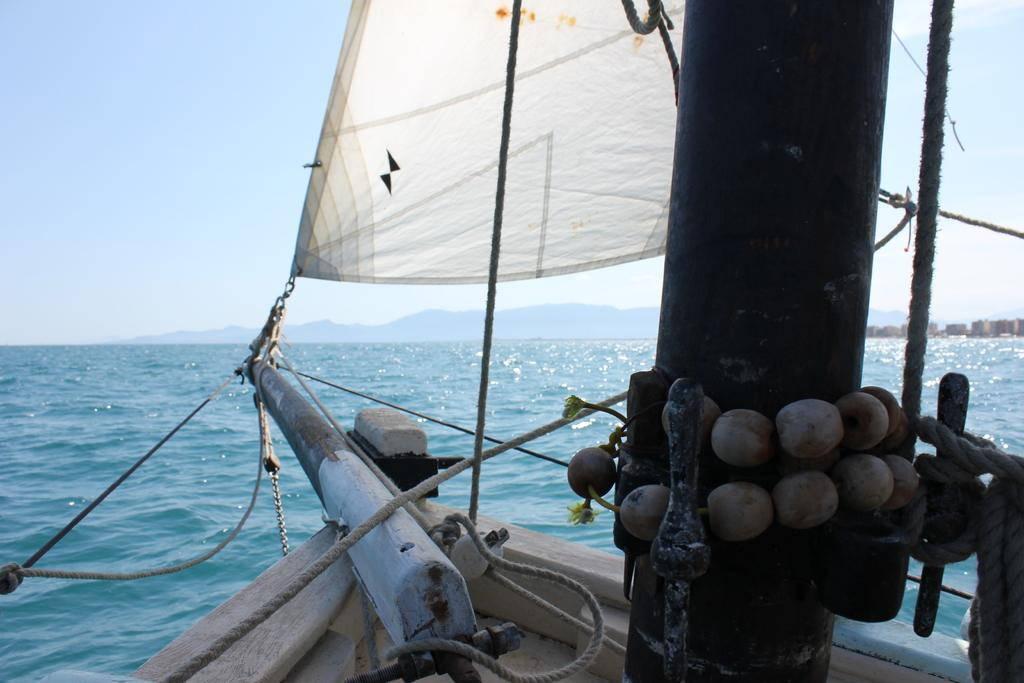What is the main subject of the image? The main subject of the image is a boat. Where is the boat located? The boat is on the water. What can be seen in the background of the image? Hills and buildings are visible in the background of the image. What type of body is visible in the image? There is no body present in the image; it features a boat on the water with hills and buildings in the background. 